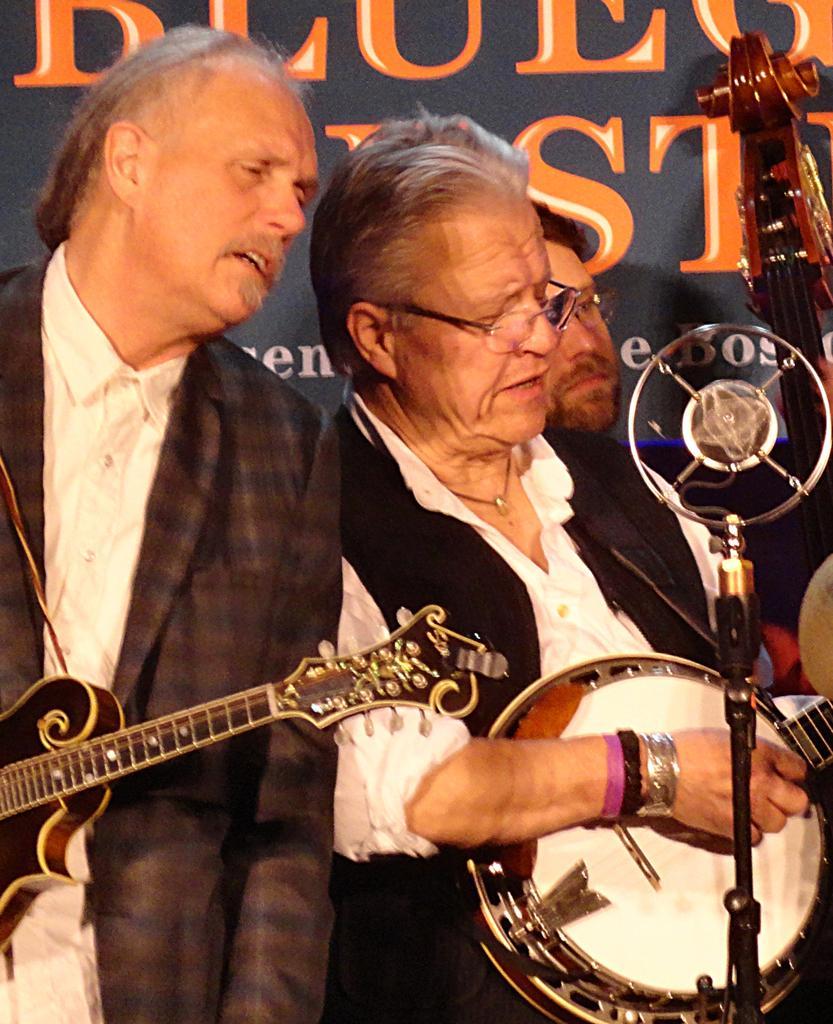Can you describe this image briefly? In this image I can see a two people standing and holding musical instruments. They are wearing white shirts and different blazers. Back I can see a black board and something is written on it. 